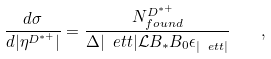Convert formula to latex. <formula><loc_0><loc_0><loc_500><loc_500>\frac { d \sigma } { d | \eta ^ { D ^ { \ast + } } | } = \frac { N ^ { D ^ { * + } } _ { f o u n d } } { \Delta | \ e t t | \mathcal { L } B _ { * } B _ { 0 } \epsilon _ { | \ e t t | } } \quad ,</formula> 